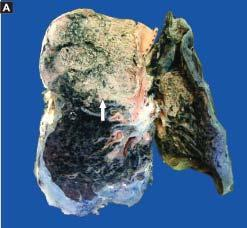what shows grey-brown, firm area of consolidation affecting a lobe?
Answer the question using a single word or phrase. The sectioned surface the lung 